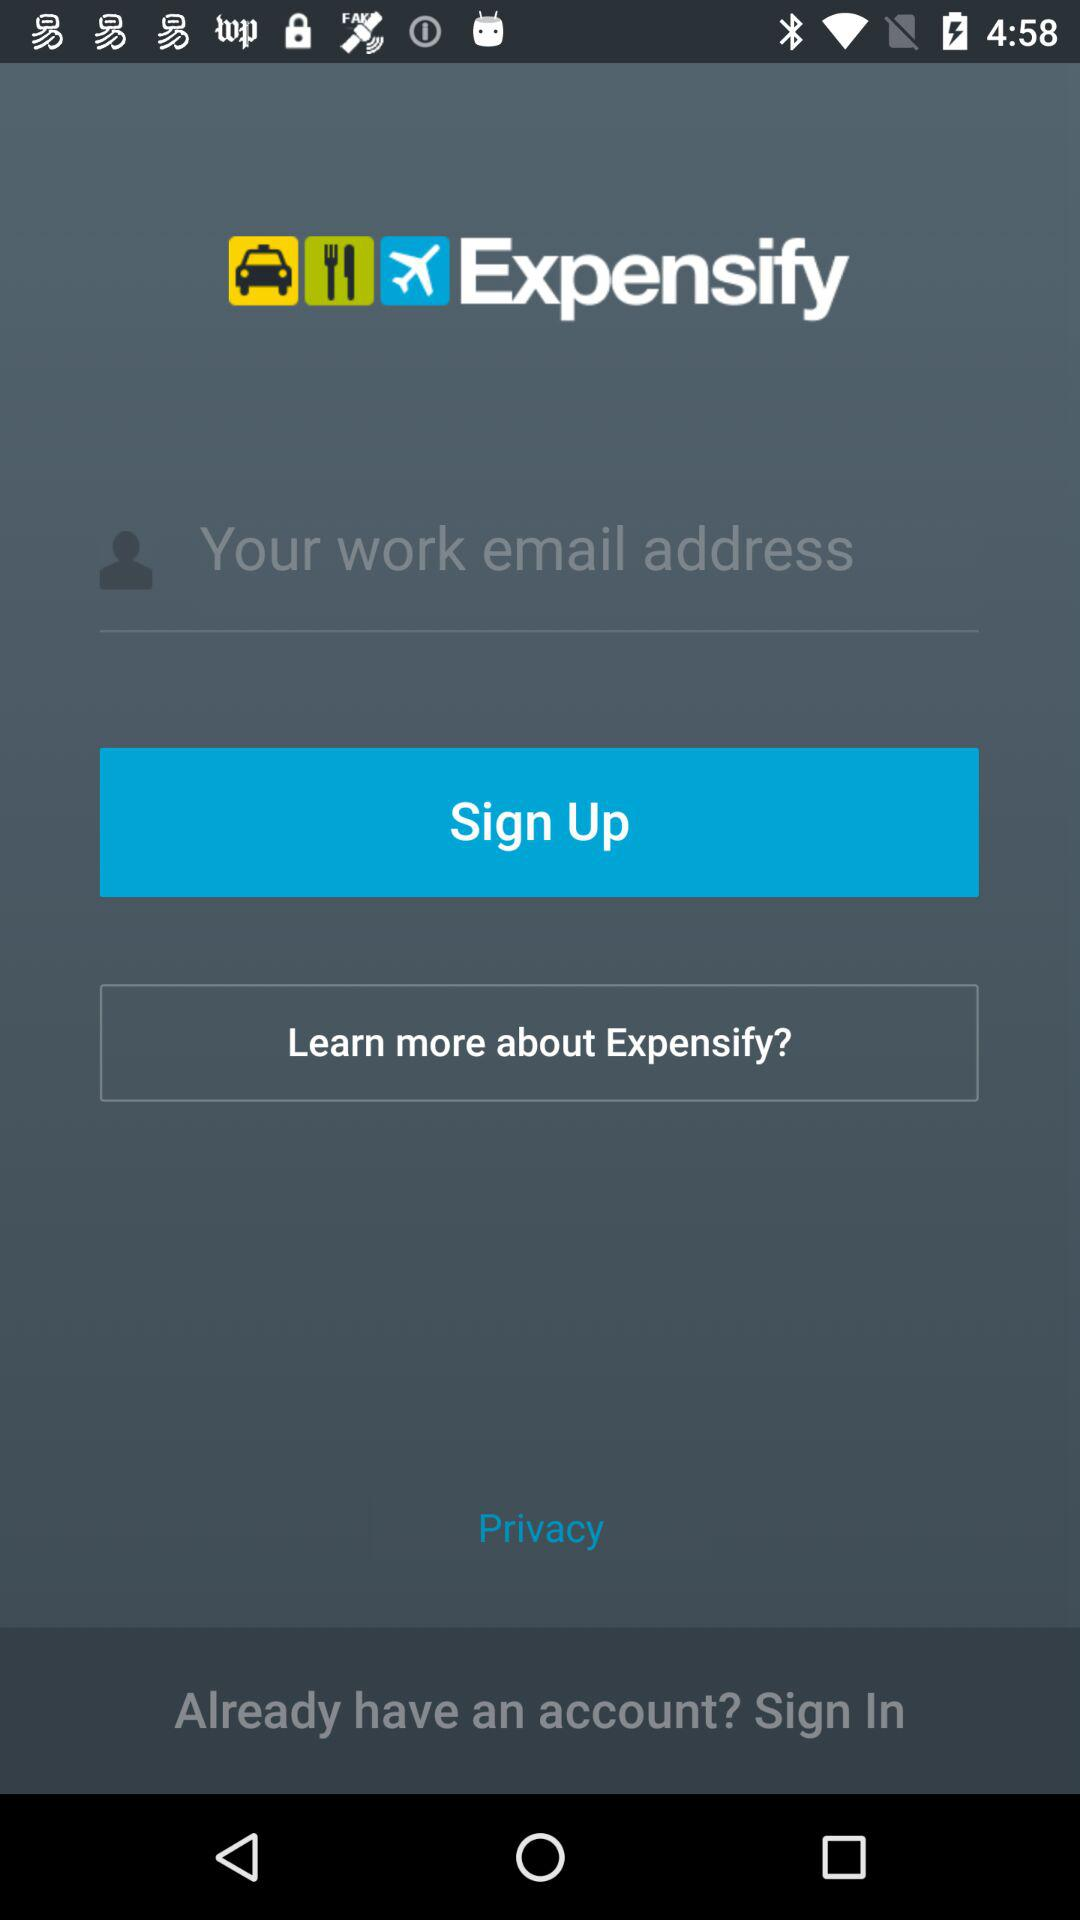What is the application name? The application name is "Expensify ". 